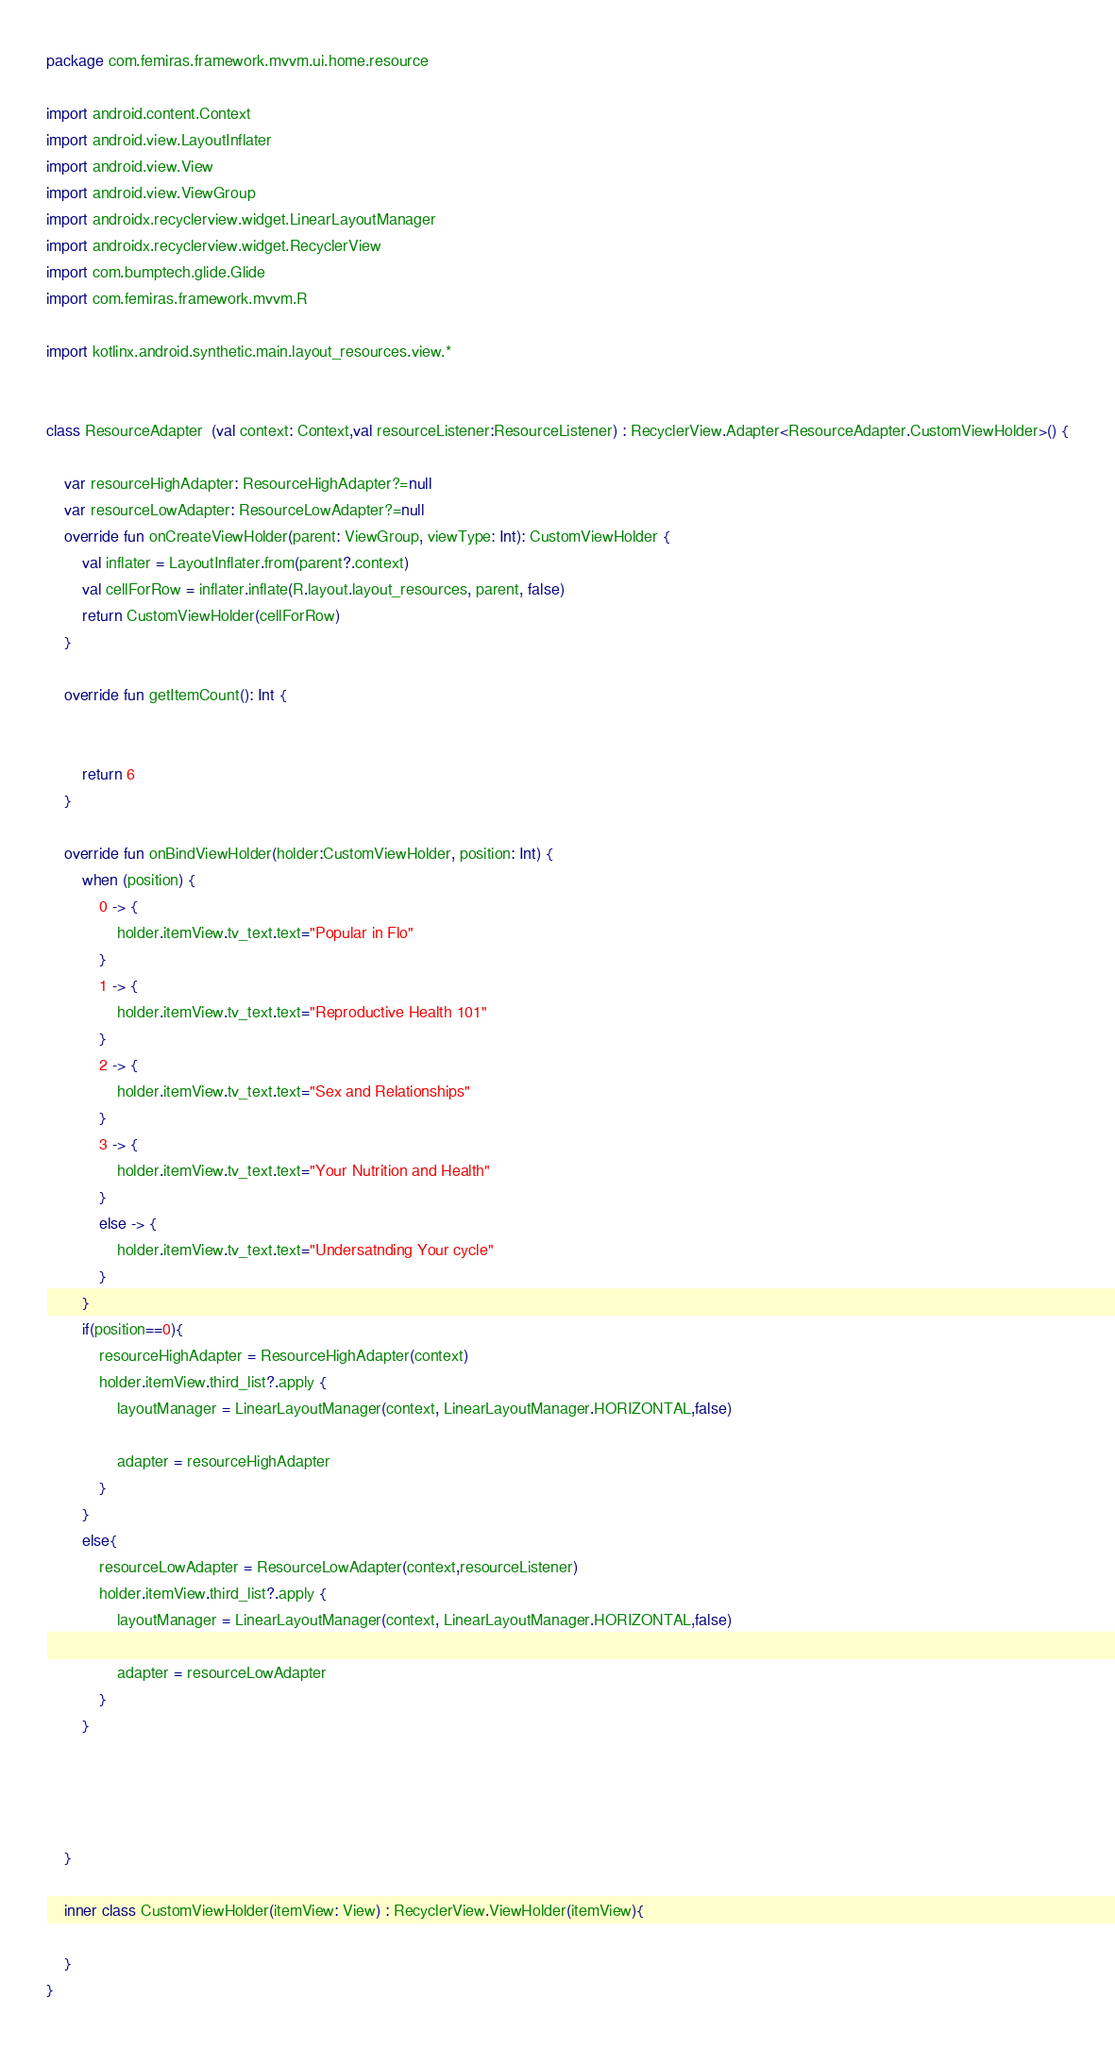Convert code to text. <code><loc_0><loc_0><loc_500><loc_500><_Kotlin_>package com.femiras.framework.mvvm.ui.home.resource

import android.content.Context
import android.view.LayoutInflater
import android.view.View
import android.view.ViewGroup
import androidx.recyclerview.widget.LinearLayoutManager
import androidx.recyclerview.widget.RecyclerView
import com.bumptech.glide.Glide
import com.femiras.framework.mvvm.R

import kotlinx.android.synthetic.main.layout_resources.view.*


class ResourceAdapter  (val context: Context,val resourceListener:ResourceListener) : RecyclerView.Adapter<ResourceAdapter.CustomViewHolder>() {

    var resourceHighAdapter: ResourceHighAdapter?=null
    var resourceLowAdapter: ResourceLowAdapter?=null
    override fun onCreateViewHolder(parent: ViewGroup, viewType: Int): CustomViewHolder {
        val inflater = LayoutInflater.from(parent?.context)
        val cellForRow = inflater.inflate(R.layout.layout_resources, parent, false)
        return CustomViewHolder(cellForRow)
    }

    override fun getItemCount(): Int {


        return 6
    }

    override fun onBindViewHolder(holder:CustomViewHolder, position: Int) {
        when (position) {
            0 -> {
                holder.itemView.tv_text.text="Popular in Flo"
            }
            1 -> {
                holder.itemView.tv_text.text="Reproductive Health 101"
            }
            2 -> {
                holder.itemView.tv_text.text="Sex and Relationships"
            }
            3 -> {
                holder.itemView.tv_text.text="Your Nutrition and Health"
            }
            else -> {
                holder.itemView.tv_text.text="Undersatnding Your cycle"
            }
        }
        if(position==0){
            resourceHighAdapter = ResourceHighAdapter(context)
            holder.itemView.third_list?.apply {
                layoutManager = LinearLayoutManager(context, LinearLayoutManager.HORIZONTAL,false)

                adapter = resourceHighAdapter
            }
        }
        else{
            resourceLowAdapter = ResourceLowAdapter(context,resourceListener)
            holder.itemView.third_list?.apply {
                layoutManager = LinearLayoutManager(context, LinearLayoutManager.HORIZONTAL,false)

                adapter = resourceLowAdapter
            }
        }




    }

    inner class CustomViewHolder(itemView: View) : RecyclerView.ViewHolder(itemView){

    }
}</code> 